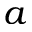<formula> <loc_0><loc_0><loc_500><loc_500>a</formula> 